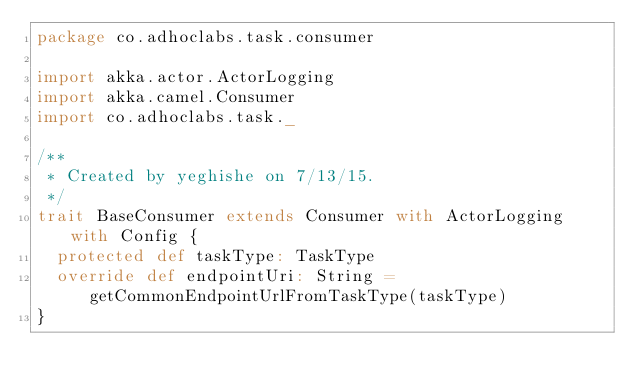Convert code to text. <code><loc_0><loc_0><loc_500><loc_500><_Scala_>package co.adhoclabs.task.consumer

import akka.actor.ActorLogging
import akka.camel.Consumer
import co.adhoclabs.task._

/**
 * Created by yeghishe on 7/13/15.
 */
trait BaseConsumer extends Consumer with ActorLogging with Config {
  protected def taskType: TaskType
  override def endpointUri: String = getCommonEndpointUrlFromTaskType(taskType)
}
</code> 